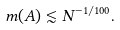<formula> <loc_0><loc_0><loc_500><loc_500>m ( A ) \lesssim N ^ { - 1 / 1 0 0 } .</formula> 